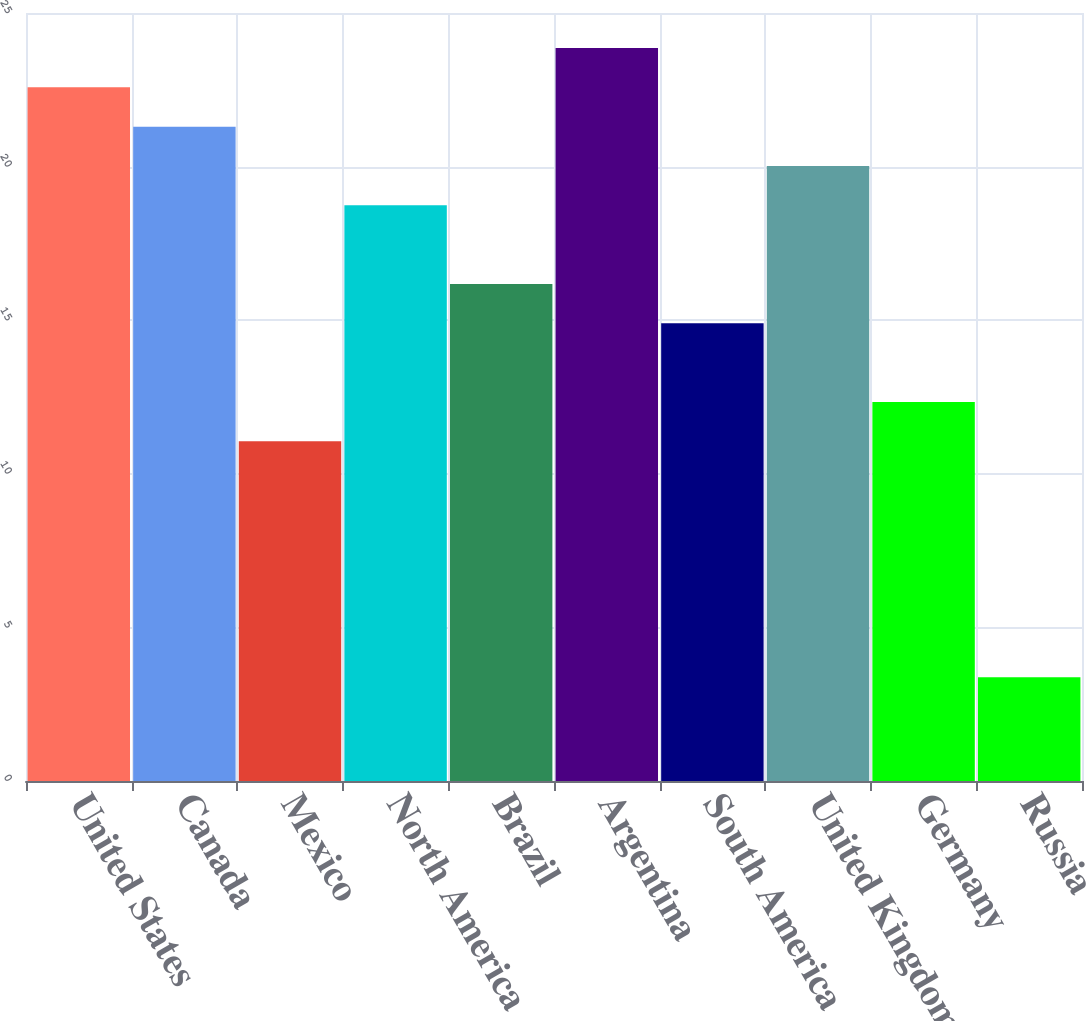Convert chart to OTSL. <chart><loc_0><loc_0><loc_500><loc_500><bar_chart><fcel>United States<fcel>Canada<fcel>Mexico<fcel>North America<fcel>Brazil<fcel>Argentina<fcel>South America<fcel>United Kingdom<fcel>Germany<fcel>Russia<nl><fcel>22.58<fcel>21.3<fcel>11.06<fcel>18.74<fcel>16.18<fcel>23.86<fcel>14.9<fcel>20.02<fcel>12.34<fcel>3.38<nl></chart> 